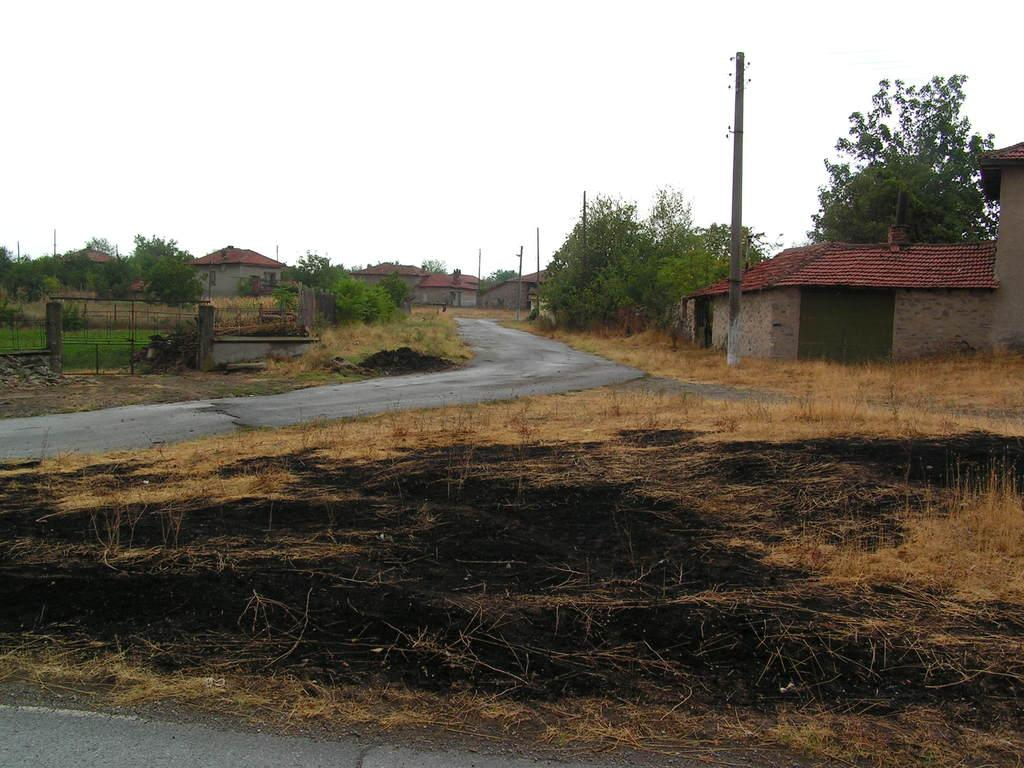What type of structures can be seen in the image? There are houses in the image. What natural elements are present in the image? There are trees and plants in the image. What type of ground cover is visible in the image? There is dry grass in the image. What man-made objects can be seen in the image? There are poles in the image. What type of verse is being recited by the person wearing a scarf and vest in the image? There is no person wearing a scarf and vest in the image, nor is there any verse being recited. 